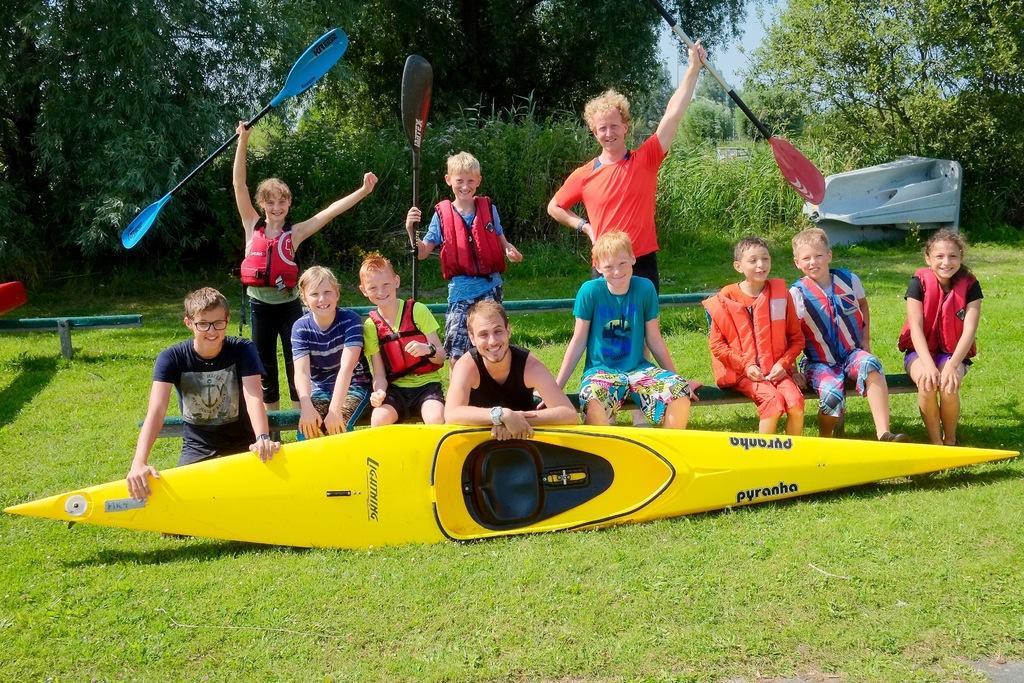Could you give a brief overview of what you see in this image? In this image there are a few people standing and a few sitting on a bench. In front of them there is a kayak on the ground. There is grass on the ground. The people who are standing here holding paddles in their hands. In the background there are plants and trees. At the top there is the sky. 